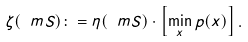<formula> <loc_0><loc_0><loc_500><loc_500>\zeta ( \ m S ) \colon = \eta ( \ m S ) \cdot \left [ \min _ { x } p ( x ) \right ] .</formula> 